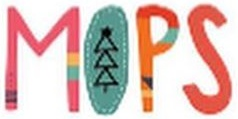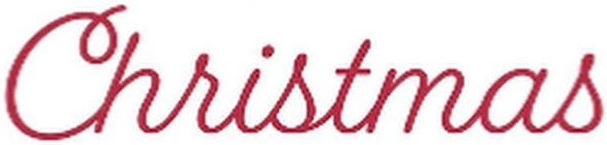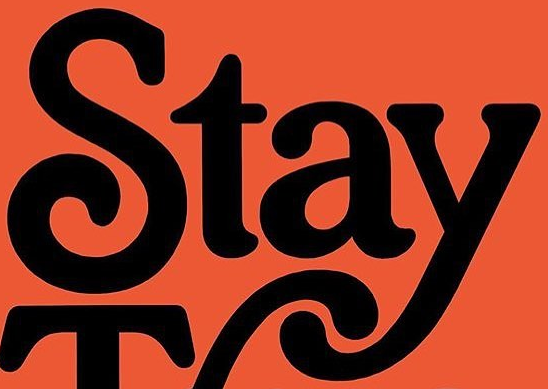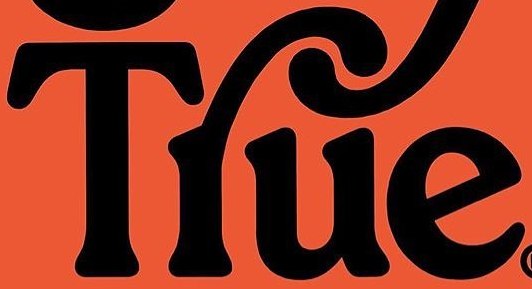Identify the words shown in these images in order, separated by a semicolon. MOPS; Christmas; Stay; Tlue 